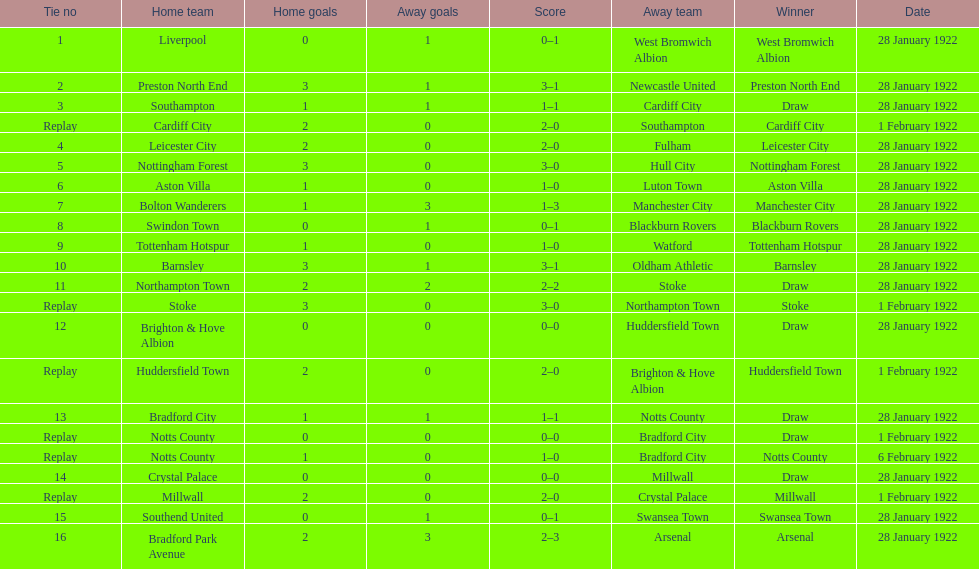What date did they play before feb 1? 28 January 1922. 